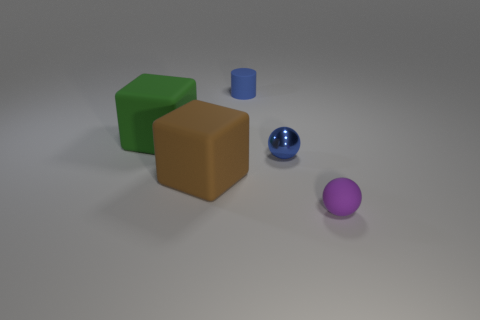There is a sphere that is the same color as the tiny rubber cylinder; what is it made of?
Keep it short and to the point. Metal. Is there a object of the same color as the cylinder?
Provide a short and direct response. Yes. Do the brown matte object and the purple rubber sphere have the same size?
Ensure brevity in your answer.  No. Is the small matte cylinder the same color as the shiny ball?
Provide a succinct answer. Yes. Do the tiny matte thing behind the tiny metal ball and the tiny metallic ball have the same color?
Offer a very short reply. Yes. There is a matte thing that is behind the large brown object and to the right of the large green thing; what is its color?
Offer a terse response. Blue. There is a small blue object that is to the right of the cylinder; what is it made of?
Give a very brief answer. Metal. What size is the green rubber object?
Your answer should be compact. Large. What number of blue things are either matte balls or cylinders?
Keep it short and to the point. 1. There is a block that is right of the large rubber thing behind the shiny sphere; how big is it?
Provide a short and direct response. Large. 